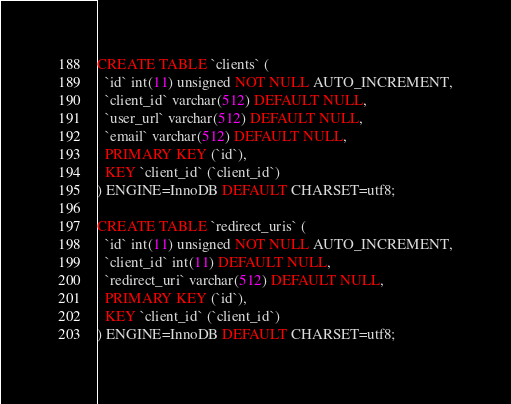Convert code to text. <code><loc_0><loc_0><loc_500><loc_500><_SQL_>CREATE TABLE `clients` (
  `id` int(11) unsigned NOT NULL AUTO_INCREMENT,
  `client_id` varchar(512) DEFAULT NULL,
  `user_url` varchar(512) DEFAULT NULL,
  `email` varchar(512) DEFAULT NULL,
  PRIMARY KEY (`id`),
  KEY `client_id` (`client_id`)
) ENGINE=InnoDB DEFAULT CHARSET=utf8;

CREATE TABLE `redirect_uris` (
  `id` int(11) unsigned NOT NULL AUTO_INCREMENT,
  `client_id` int(11) DEFAULT NULL,
  `redirect_uri` varchar(512) DEFAULT NULL,
  PRIMARY KEY (`id`),
  KEY `client_id` (`client_id`)
) ENGINE=InnoDB DEFAULT CHARSET=utf8;

</code> 